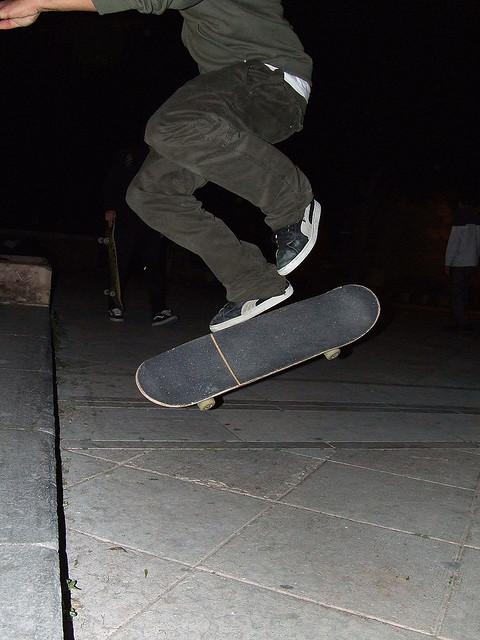Is this person proficient at what he does?
Be succinct. Yes. What is flying in the air?
Short answer required. Skateboard. How many steps are visible?
Keep it brief. 0. Is he about to fall?
Quick response, please. No. How can we tell it's nighttime?
Concise answer only. Its dark. 